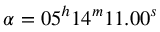<formula> <loc_0><loc_0><loc_500><loc_500>\alpha = 0 5 ^ { h } 1 4 ^ { m } 1 1 . 0 0 ^ { s }</formula> 